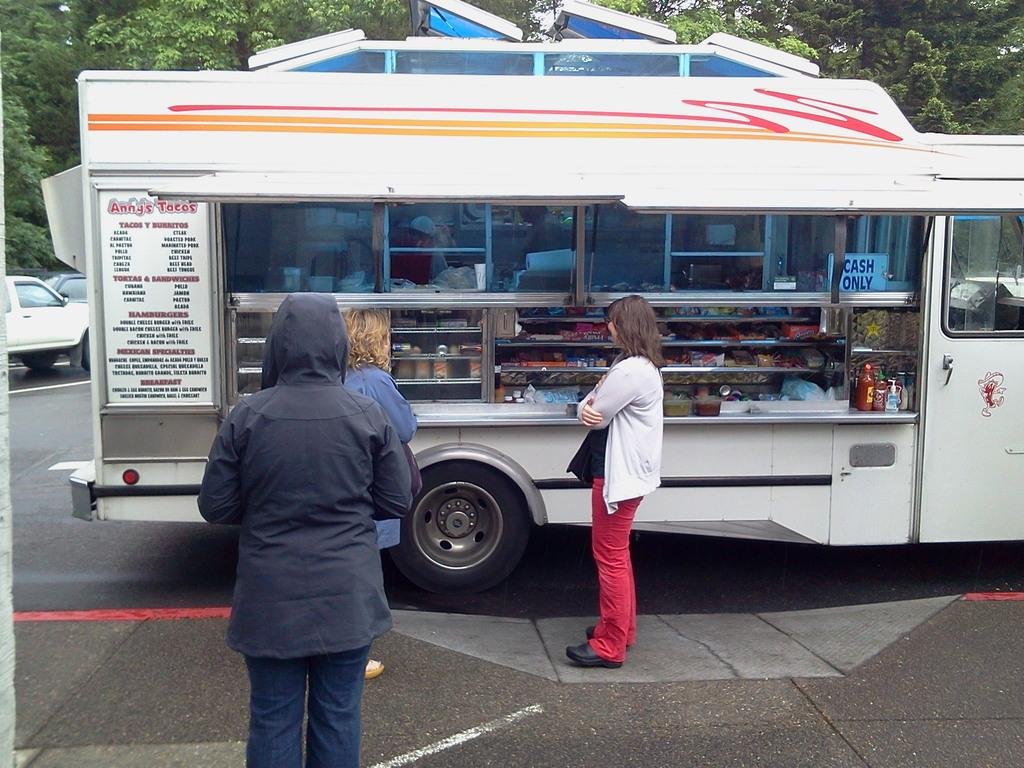What is the main subject in the center of the image? There is a food truck in the center of the image. What can be seen near the food truck? There are persons near the food truck. What is visible in the background of the image? There are vehicles and trees in the background of the image. Can you see any planes flying in the image? There are no planes visible in the image. Is there an apple on the food truck in the image? There is no apple present on the food truck in the image. 